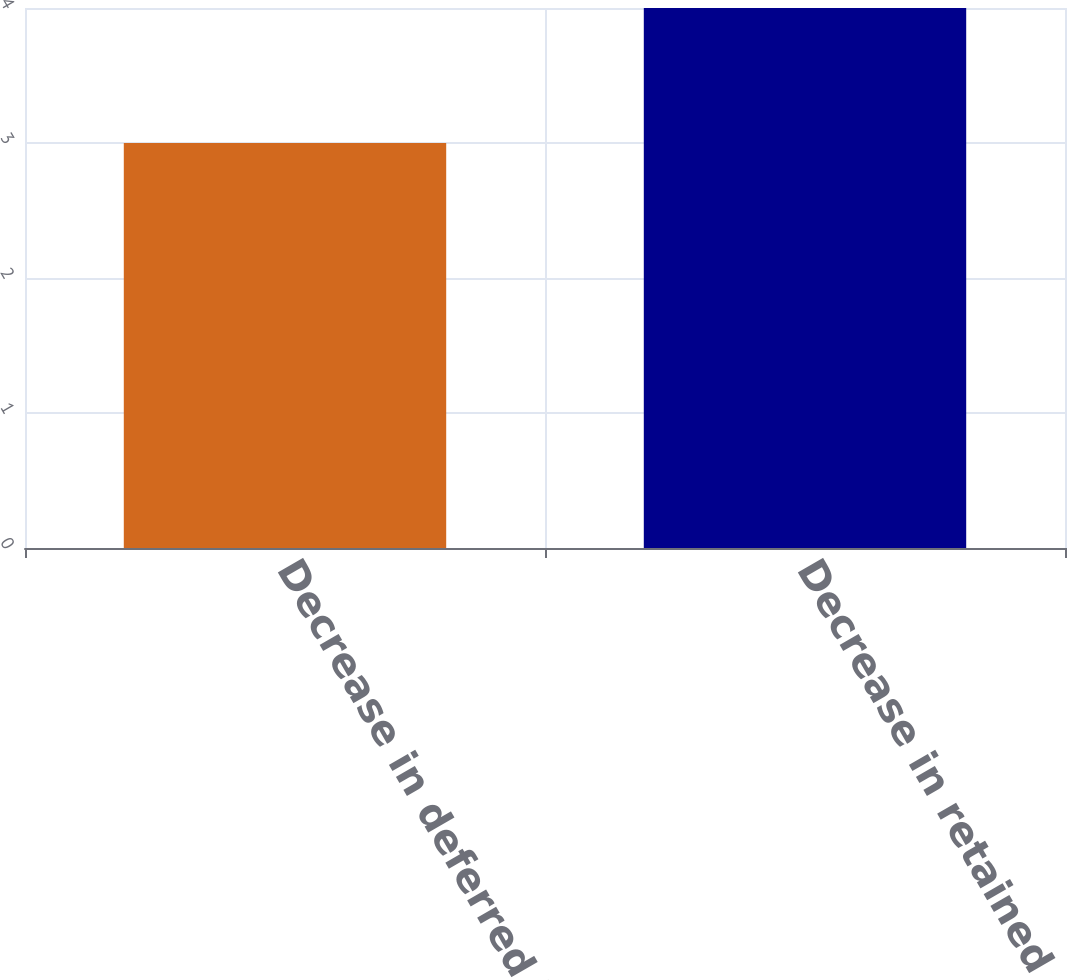Convert chart. <chart><loc_0><loc_0><loc_500><loc_500><bar_chart><fcel>Decrease in deferred income<fcel>Decrease in retained earnings<nl><fcel>3<fcel>4<nl></chart> 